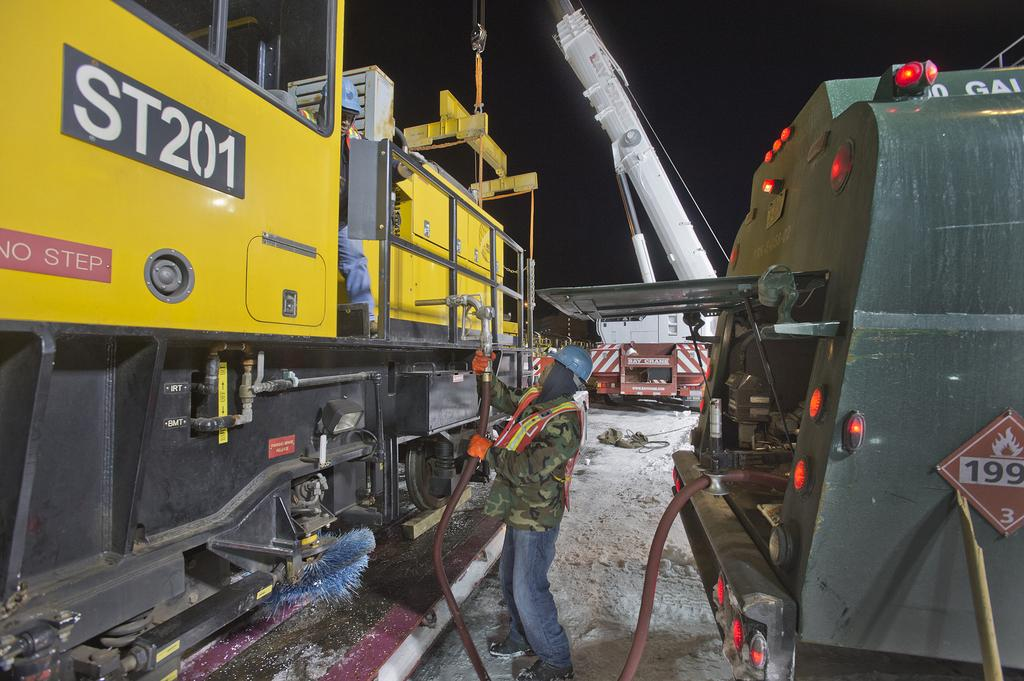Provide a one-sentence caption for the provided image. A large piece of industrial equipment with the number ST201 on it. 